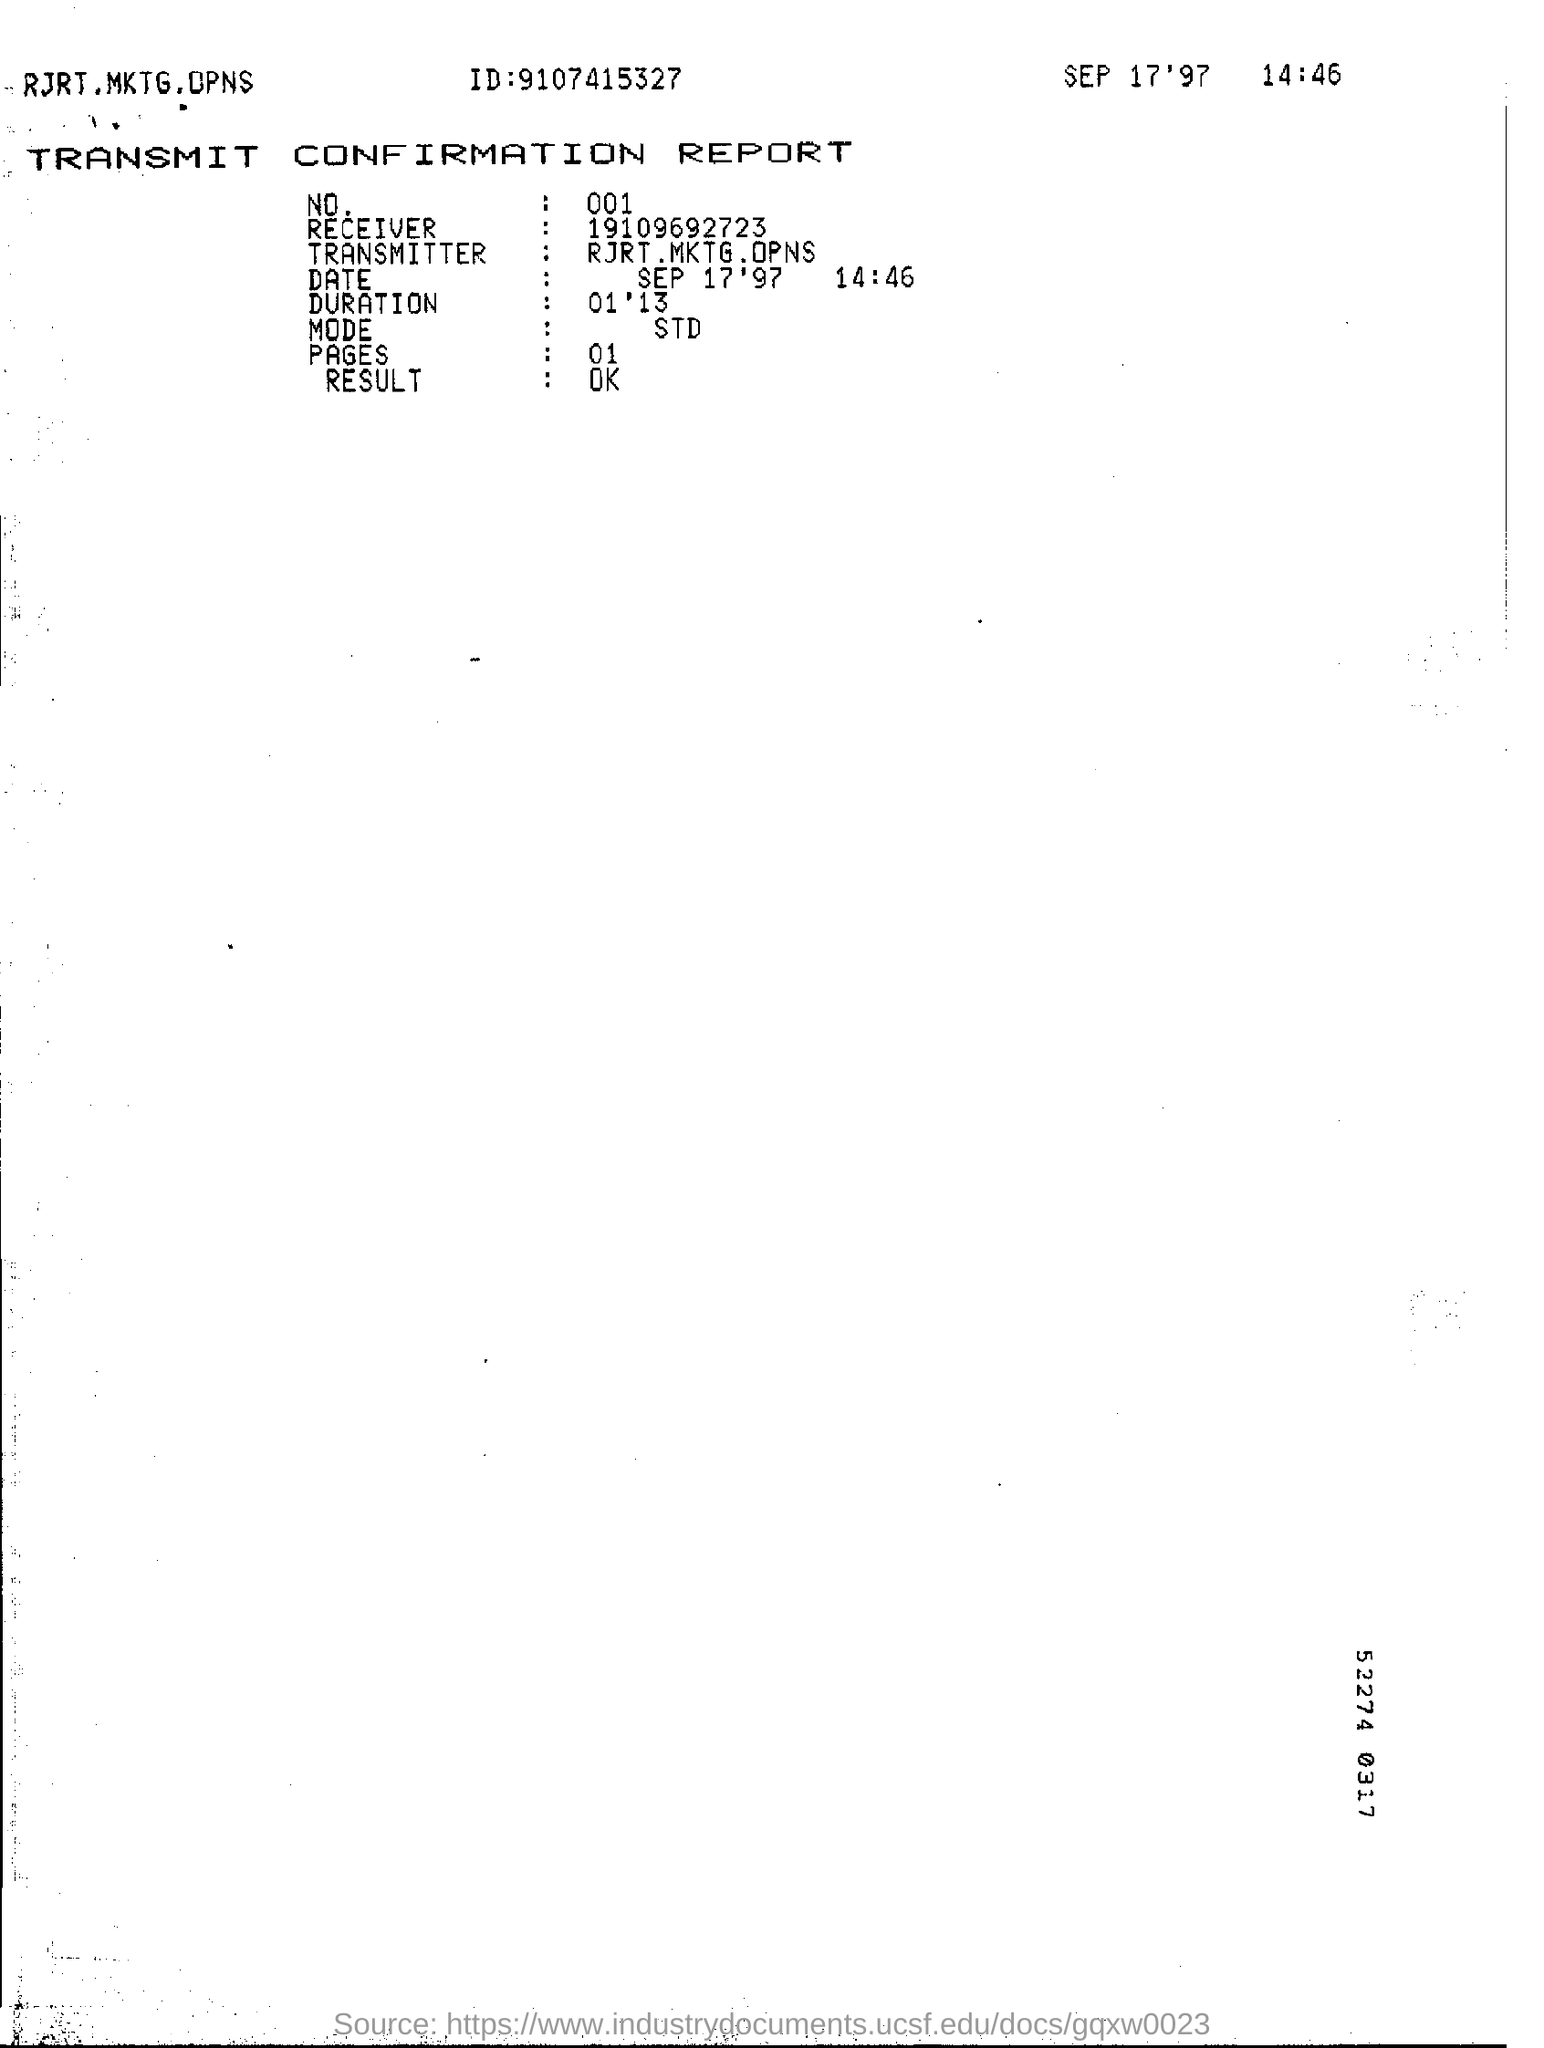What type of this Report ?
Offer a very short reply. Transmit confirmation report. What is the date mentioned in the top of the document ?
Provide a short and direct response. SEP 17'97. What is the ID Number written in the document ?
Provide a short and direct response. 9107415327. How many pages are there?
Offer a very short reply. 01. What is the Result of the Document ?
Offer a terse response. OK. Who is the Transmitter ?
Provide a succinct answer. RJRT. MKTG. OPNS. What is written in the Mode Filed ?
Provide a short and direct response. STD. What is the Receiver Number ?
Your response must be concise. 19109692723. 